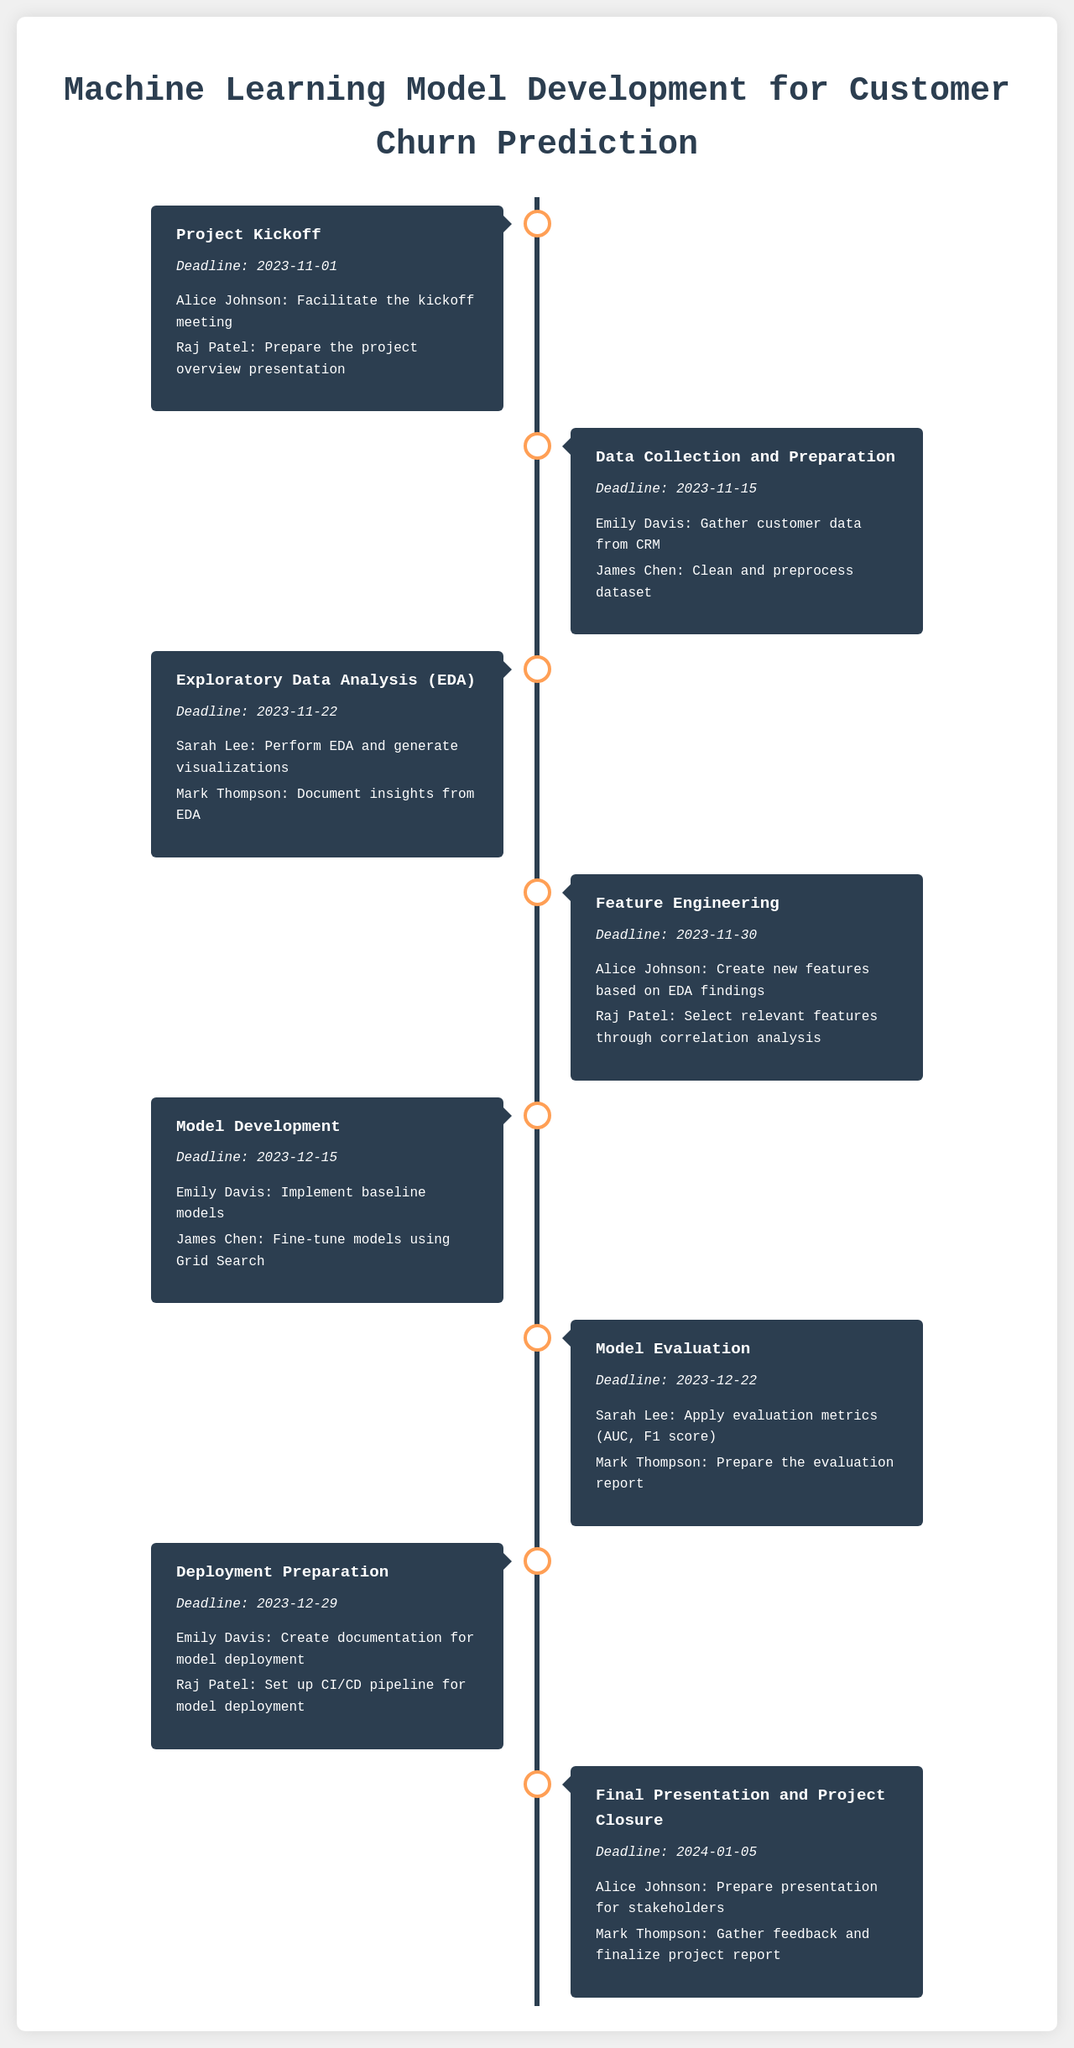What is the deadline for Project Kickoff? The deadline for Project Kickoff is explicitly stated in the document.
Answer: 2023-11-01 Who is responsible for preparing the project overview presentation? This task is assigned to a specific individual within the timeline.
Answer: Raj Patel What is the title of the project? The title of the project is clearly mentioned at the beginning of the document.
Answer: Machine Learning Model Development for Customer Churn Prediction How many milestones are listed in the document? The total number of milestones can be counted from the timeline sections.
Answer: 8 What is the deadline for the Model Development milestone? The deadline for Model Development is provided as part of the milestone details.
Answer: 2023-12-15 Which task must be completed by Sarah Lee in the Model Evaluation phase? This task is specified as part of the responsibilities associated with the milestone.
Answer: Apply evaluation metrics (AUC, F1 score) Who is involved in the Final Presentation and Project Closure? The document assigns specific individuals to the final milestone tasks.
Answer: Alice Johnson, Mark Thompson When is the final deadline for the project? The final deadline can be identified from the last milestone in the timeline.
Answer: 2024-01-05 